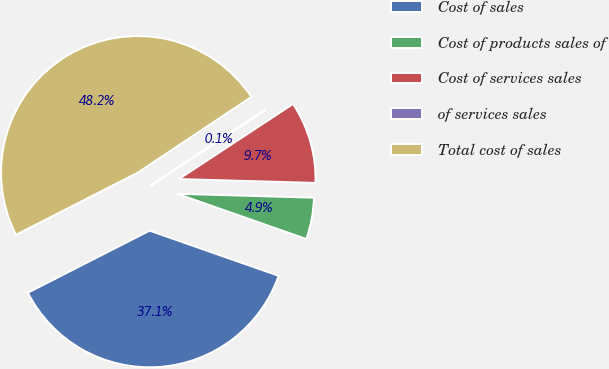Convert chart. <chart><loc_0><loc_0><loc_500><loc_500><pie_chart><fcel>Cost of sales<fcel>Cost of products sales of<fcel>Cost of services sales<fcel>of services sales<fcel>Total cost of sales<nl><fcel>37.13%<fcel>4.91%<fcel>9.71%<fcel>0.1%<fcel>48.15%<nl></chart> 